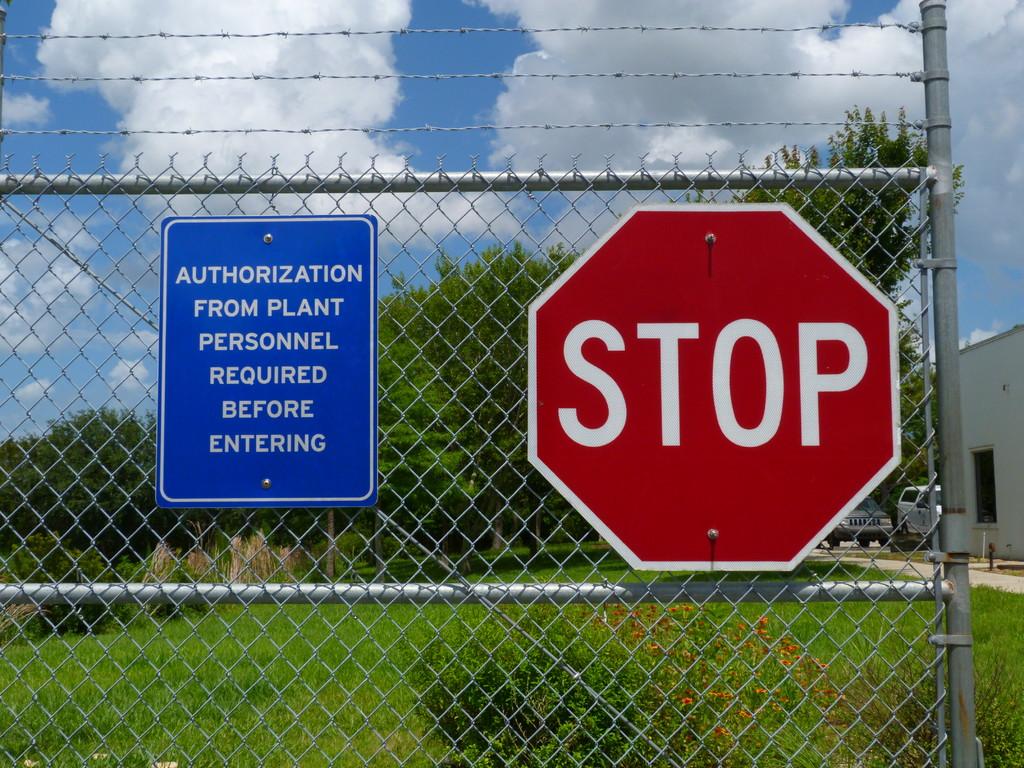Who do you need to authorization from to enter?
Your answer should be very brief. Plant personnel. Must you have approval prior to entering?
Provide a short and direct response. Yes. 